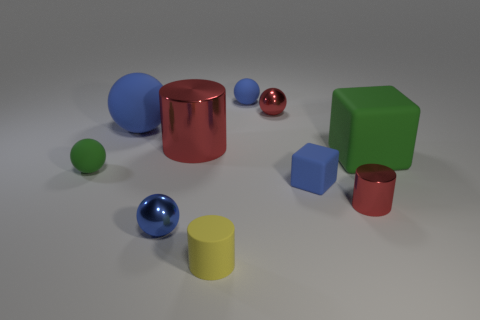How many blue balls must be subtracted to get 1 blue balls? 2 Subtract all large spheres. How many spheres are left? 4 Subtract all gray cylinders. How many blue spheres are left? 3 Subtract all green spheres. How many spheres are left? 4 Subtract 1 cylinders. How many cylinders are left? 2 Subtract all purple balls. Subtract all brown cylinders. How many balls are left? 5 Subtract all cylinders. How many objects are left? 7 Subtract all rubber blocks. Subtract all small red shiny objects. How many objects are left? 6 Add 3 tiny cylinders. How many tiny cylinders are left? 5 Add 1 blue rubber blocks. How many blue rubber blocks exist? 2 